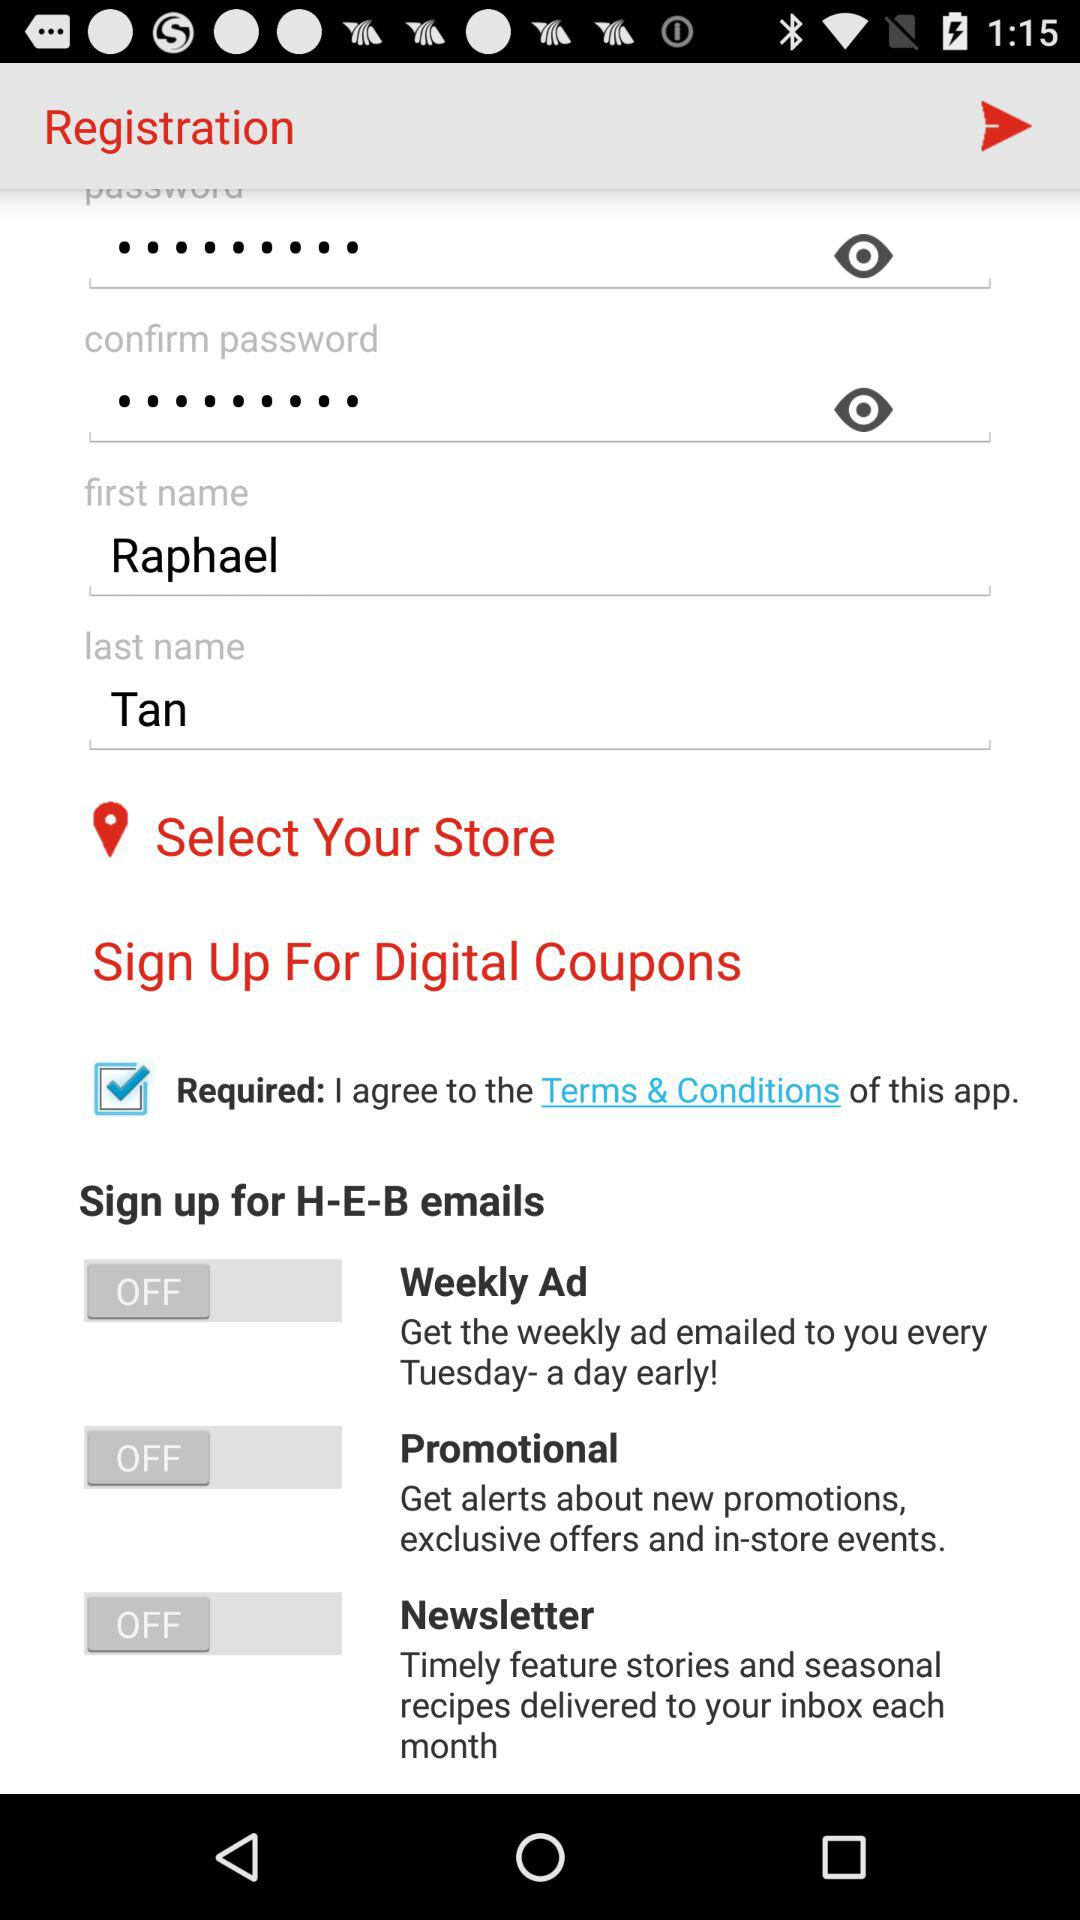What is the last name of the user? The last name of the user is Tan. 